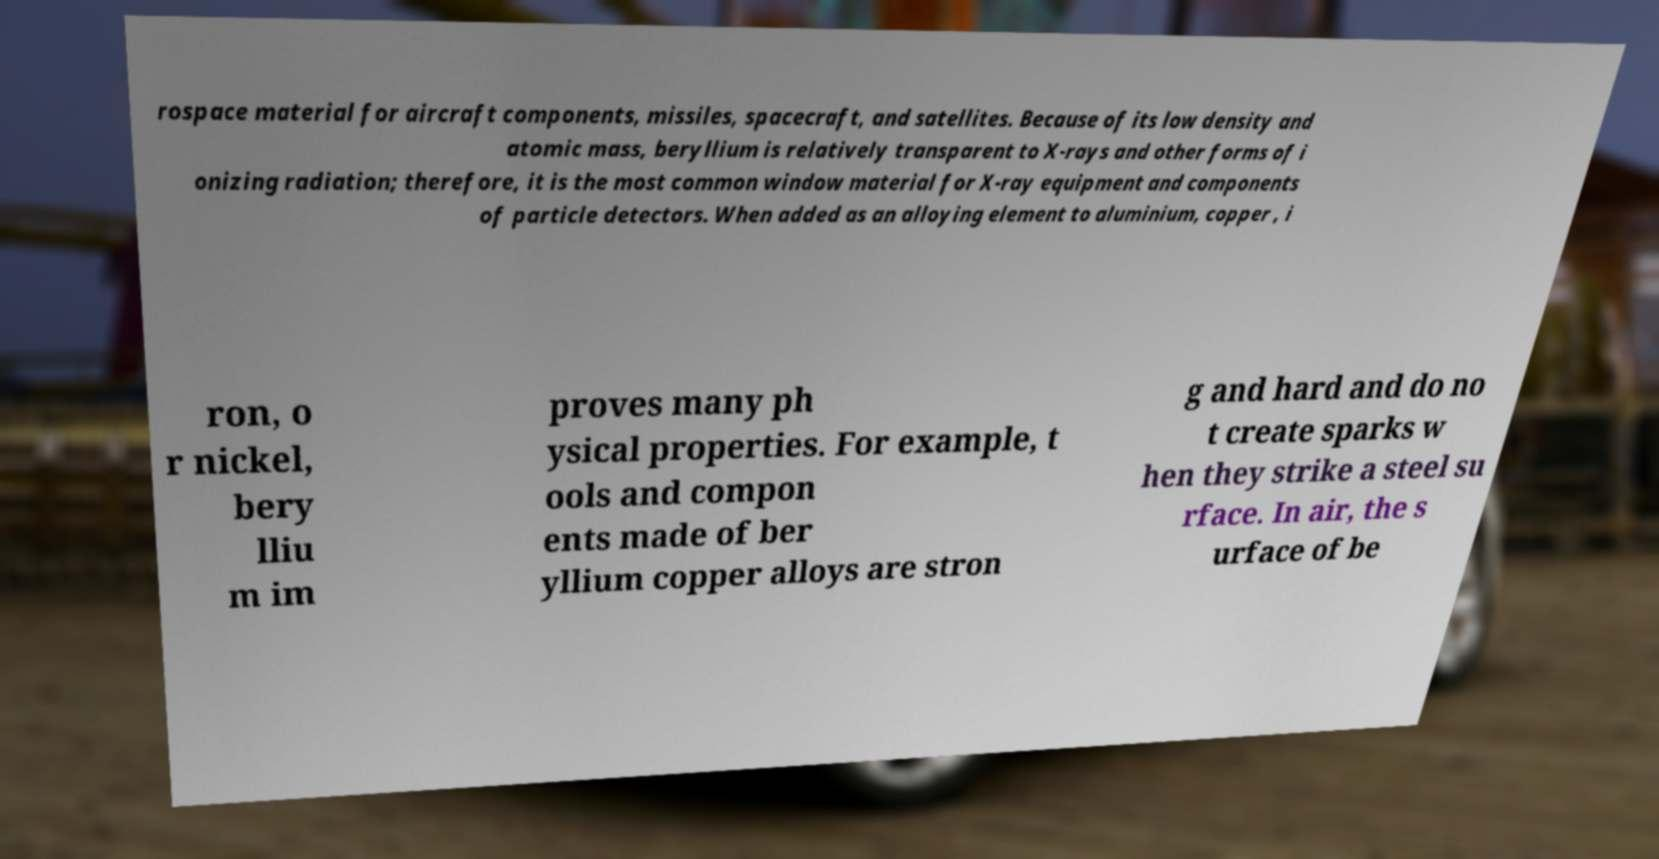There's text embedded in this image that I need extracted. Can you transcribe it verbatim? rospace material for aircraft components, missiles, spacecraft, and satellites. Because of its low density and atomic mass, beryllium is relatively transparent to X-rays and other forms of i onizing radiation; therefore, it is the most common window material for X-ray equipment and components of particle detectors. When added as an alloying element to aluminium, copper , i ron, o r nickel, bery lliu m im proves many ph ysical properties. For example, t ools and compon ents made of ber yllium copper alloys are stron g and hard and do no t create sparks w hen they strike a steel su rface. In air, the s urface of be 